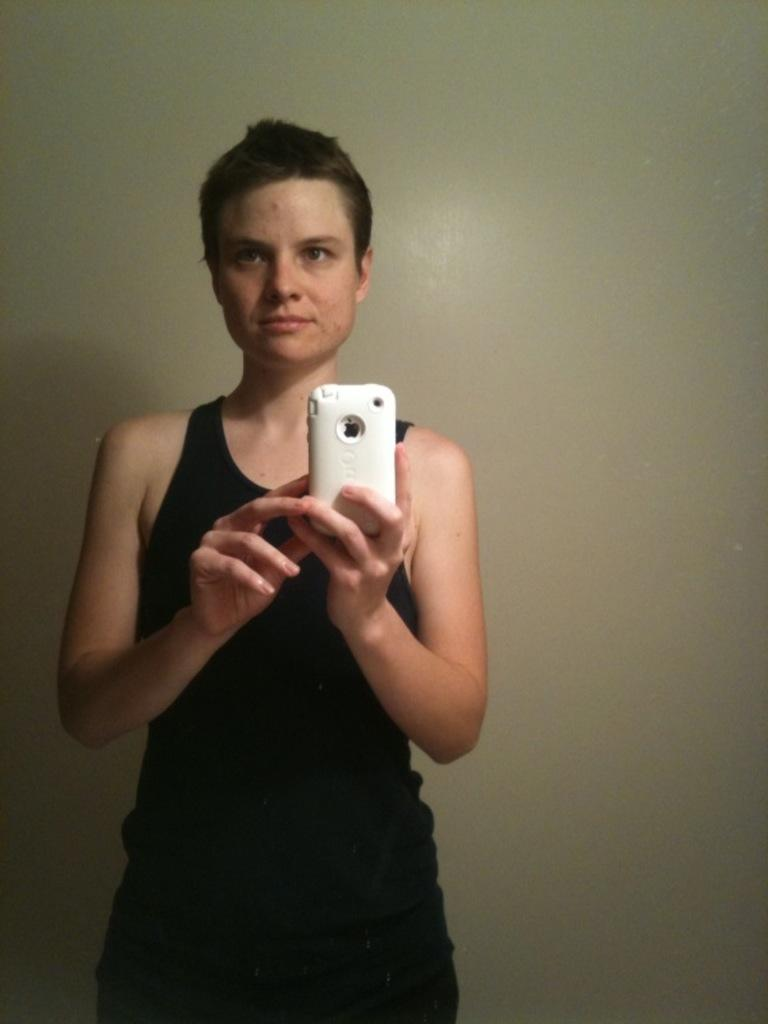What is the main subject of the image? There is a person in the image. What is the person doing in the image? The person is standing and taking a picture. How is the person holding the device used for taking the picture? The person is holding a mobile with their hands. What type of sticks can be seen in the person's hand in the image? There are no sticks visible in the person's hand in the image. Is the person holding a banana while taking the picture? There is no banana present in the image; the person is holding a mobile for taking the picture. 